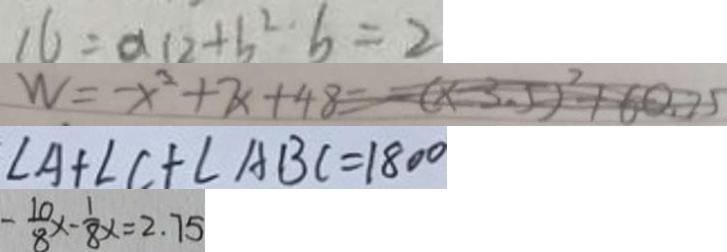<formula> <loc_0><loc_0><loc_500><loc_500>1 6 = \alpha 1 2 + b ^ { 2 } b = 2 
 W = - x ^ { 2 } + 7 x + 4 8 = ( x - 3 . 5 ) ^ { 2 } + 6 0 . 2 5 
 \angle A + \angle C + \angle A B C = 1 8 0 ^ { \circ } 
 - \frac { 1 0 } { 8 } x - \frac { 1 } { 8 } x = 2 . 7 5</formula> 